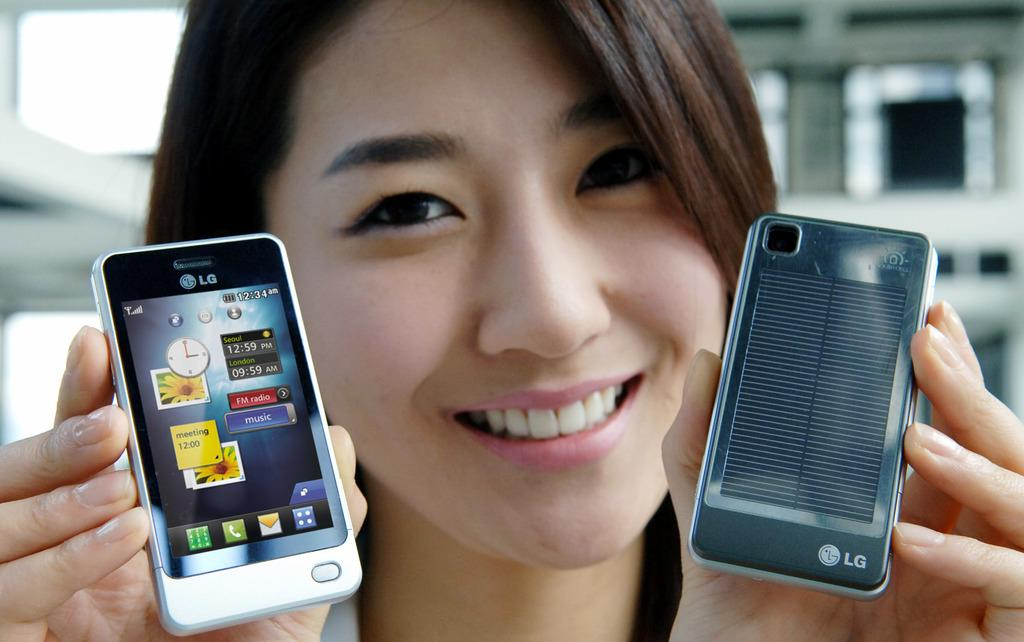<image>
Share a concise interpretation of the image provided. LG is the brand displayed on this cellphone. 